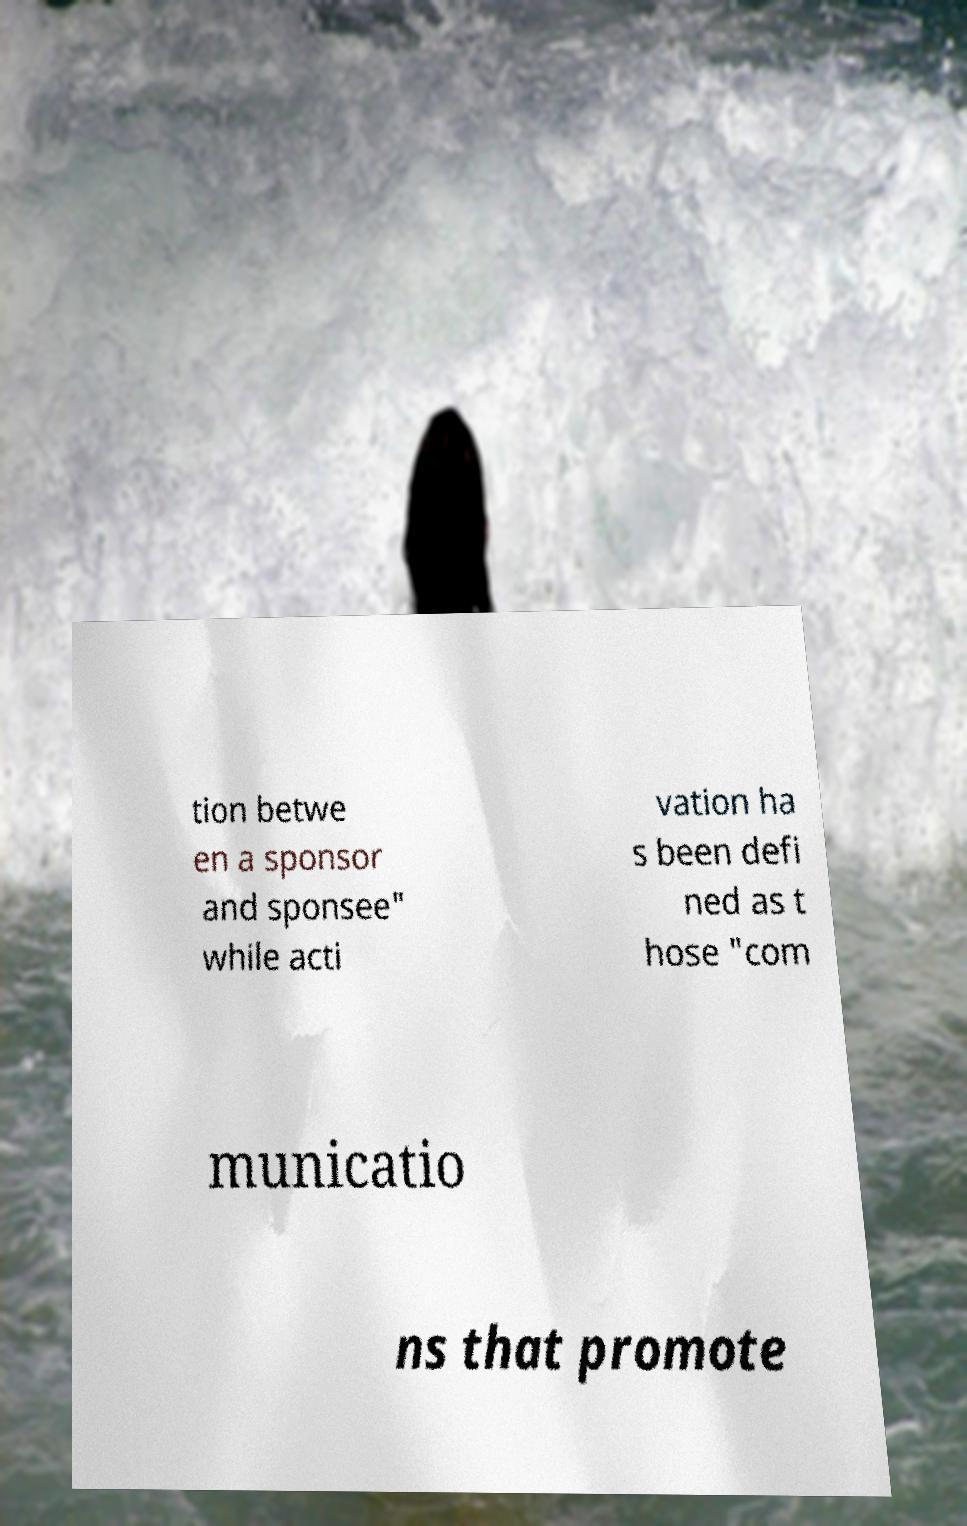Could you assist in decoding the text presented in this image and type it out clearly? tion betwe en a sponsor and sponsee" while acti vation ha s been defi ned as t hose "com municatio ns that promote 